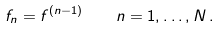Convert formula to latex. <formula><loc_0><loc_0><loc_500><loc_500>f _ { n } = f ^ { ( n - 1 ) } \, \quad n = 1 , \dots , N \, .</formula> 